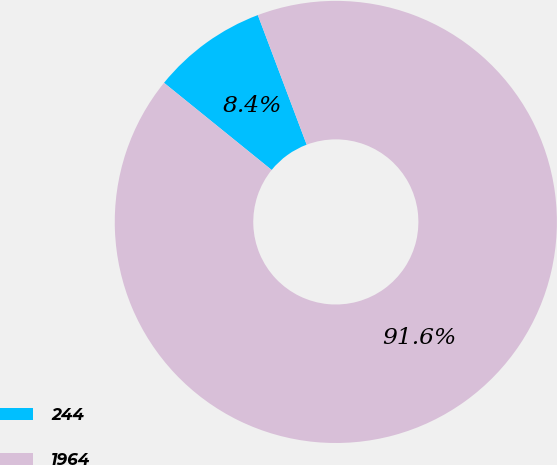<chart> <loc_0><loc_0><loc_500><loc_500><pie_chart><fcel>244<fcel>1964<nl><fcel>8.43%<fcel>91.57%<nl></chart> 